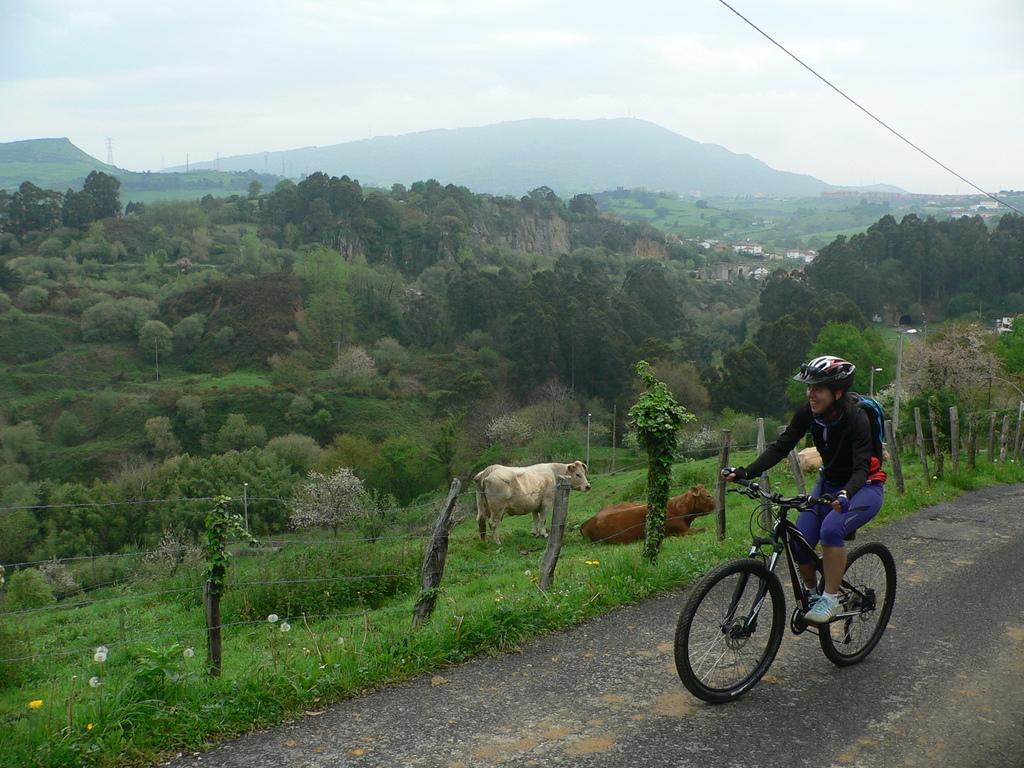Can you describe this image briefly? In this picture I can see few cows and trees, buildings and a human riding bicycle and I can see helmet on the head and backpack on the back and I can see grass and few plants and a cloudy sky. 